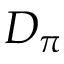<formula> <loc_0><loc_0><loc_500><loc_500>D _ { \pi }</formula> 